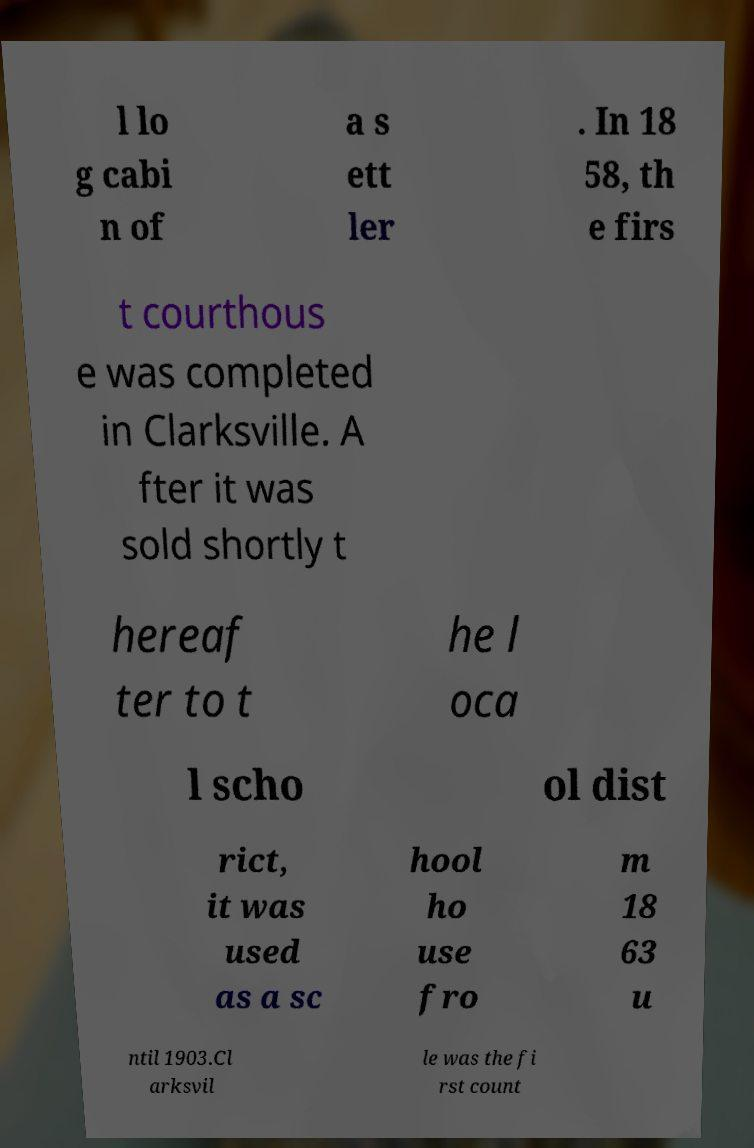Could you assist in decoding the text presented in this image and type it out clearly? l lo g cabi n of a s ett ler . In 18 58, th e firs t courthous e was completed in Clarksville. A fter it was sold shortly t hereaf ter to t he l oca l scho ol dist rict, it was used as a sc hool ho use fro m 18 63 u ntil 1903.Cl arksvil le was the fi rst count 